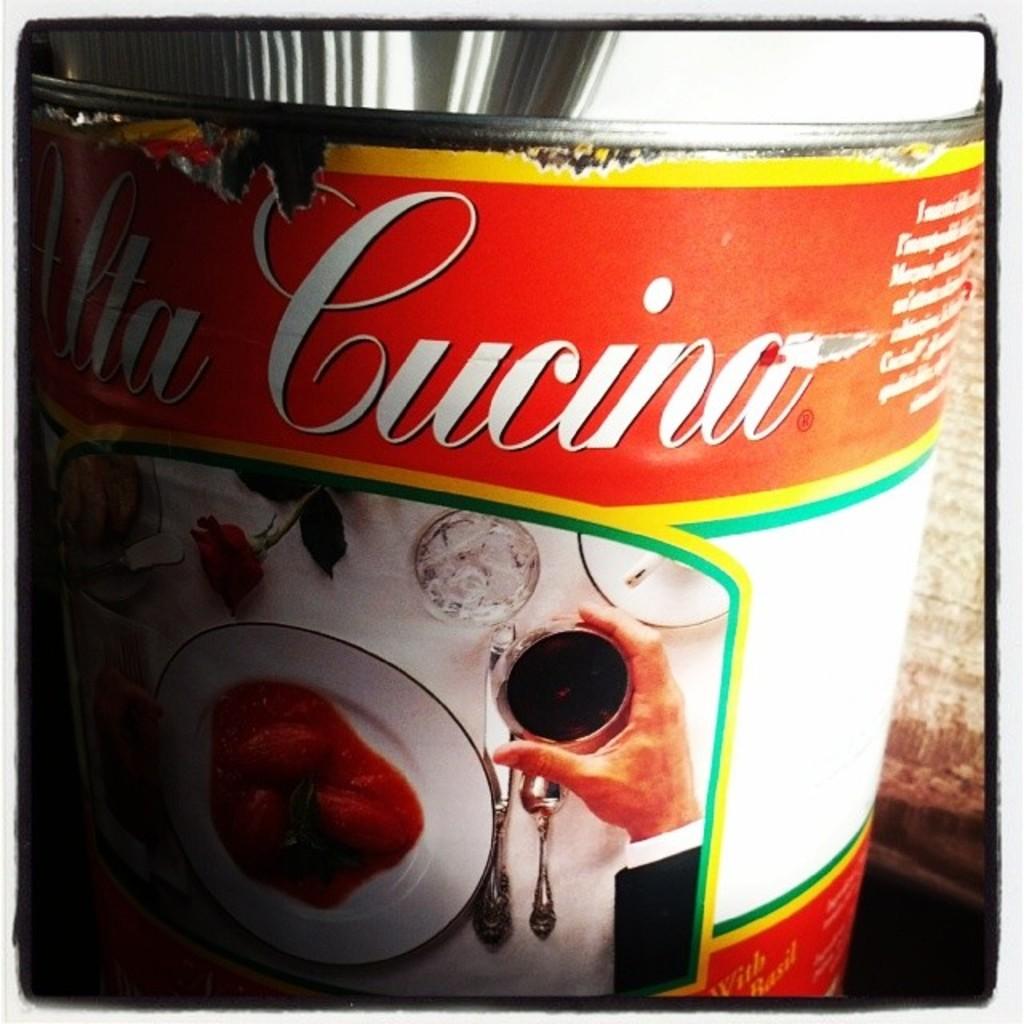What is the name of this product?
Offer a terse response. Uta cucina. Cucino product name?
Give a very brief answer. Yes. 